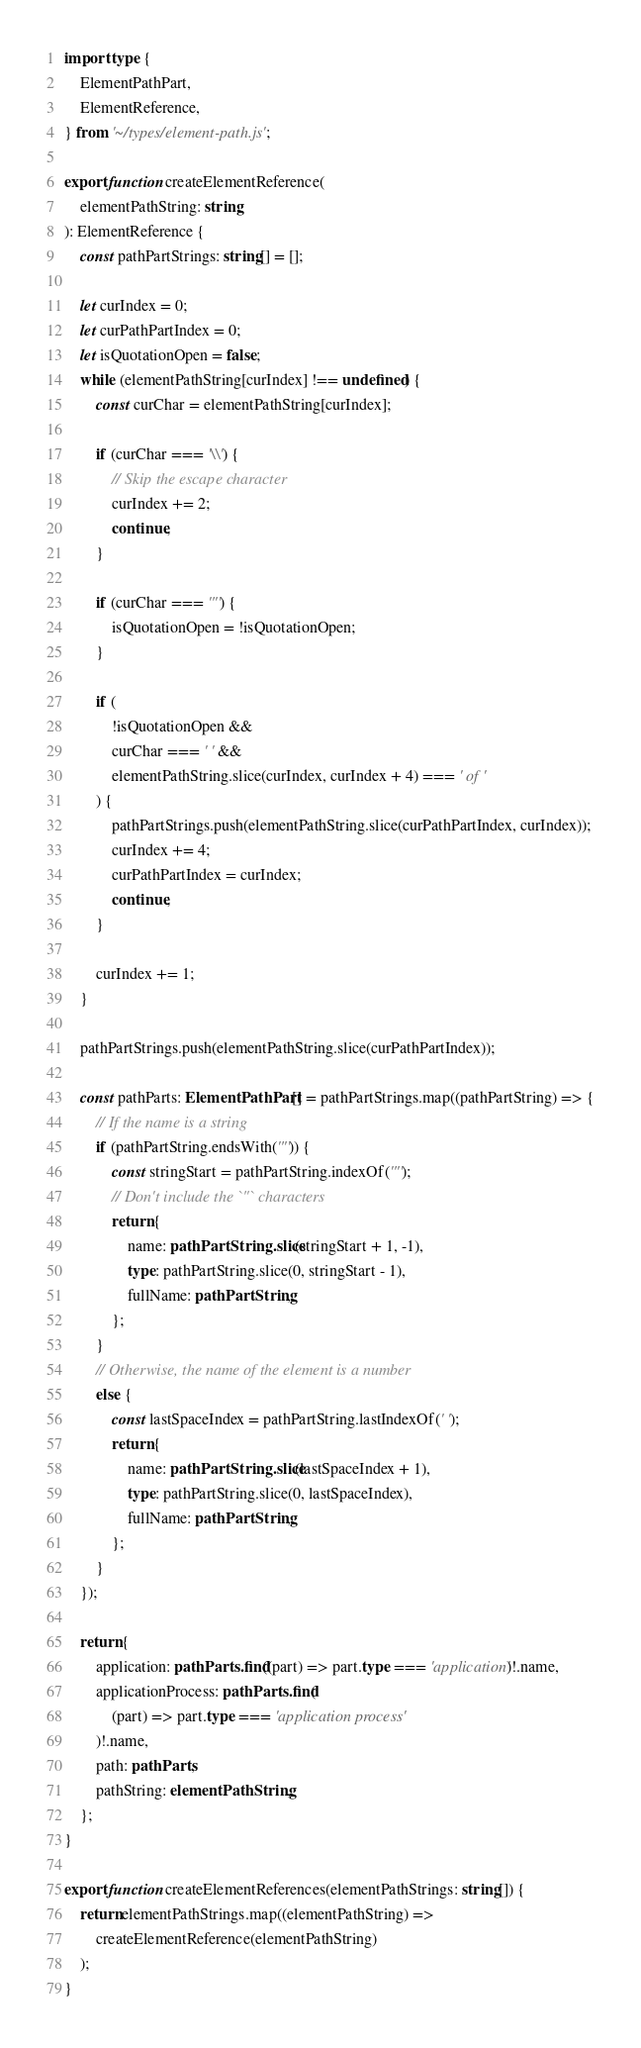Convert code to text. <code><loc_0><loc_0><loc_500><loc_500><_TypeScript_>import type {
	ElementPathPart,
	ElementReference,
} from '~/types/element-path.js';

export function createElementReference(
	elementPathString: string
): ElementReference {
	const pathPartStrings: string[] = [];

	let curIndex = 0;
	let curPathPartIndex = 0;
	let isQuotationOpen = false;
	while (elementPathString[curIndex] !== undefined) {
		const curChar = elementPathString[curIndex];

		if (curChar === '\\') {
			// Skip the escape character
			curIndex += 2;
			continue;
		}

		if (curChar === '"') {
			isQuotationOpen = !isQuotationOpen;
		}

		if (
			!isQuotationOpen &&
			curChar === ' ' &&
			elementPathString.slice(curIndex, curIndex + 4) === ' of '
		) {
			pathPartStrings.push(elementPathString.slice(curPathPartIndex, curIndex));
			curIndex += 4;
			curPathPartIndex = curIndex;
			continue;
		}

		curIndex += 1;
	}

	pathPartStrings.push(elementPathString.slice(curPathPartIndex));

	const pathParts: ElementPathPart[] = pathPartStrings.map((pathPartString) => {
		// If the name is a string
		if (pathPartString.endsWith('"')) {
			const stringStart = pathPartString.indexOf('"');
			// Don't include the `"` characters
			return {
				name: pathPartString.slice(stringStart + 1, -1),
				type: pathPartString.slice(0, stringStart - 1),
				fullName: pathPartString,
			};
		}
		// Otherwise, the name of the element is a number
		else {
			const lastSpaceIndex = pathPartString.lastIndexOf(' ');
			return {
				name: pathPartString.slice(lastSpaceIndex + 1),
				type: pathPartString.slice(0, lastSpaceIndex),
				fullName: pathPartString,
			};
		}
	});

	return {
		application: pathParts.find((part) => part.type === 'application')!.name,
		applicationProcess: pathParts.find(
			(part) => part.type === 'application process'
		)!.name,
		path: pathParts,
		pathString: elementPathString,
	};
}

export function createElementReferences(elementPathStrings: string[]) {
	return elementPathStrings.map((elementPathString) =>
		createElementReference(elementPathString)
	);
}
</code> 